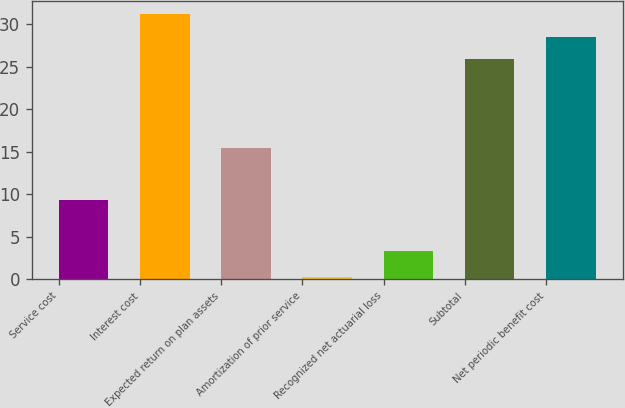Convert chart. <chart><loc_0><loc_0><loc_500><loc_500><bar_chart><fcel>Service cost<fcel>Interest cost<fcel>Expected return on plan assets<fcel>Amortization of prior service<fcel>Recognized net actuarial loss<fcel>Subtotal<fcel>Net periodic benefit cost<nl><fcel>9.3<fcel>31.22<fcel>15.5<fcel>0.3<fcel>3.3<fcel>25.9<fcel>28.56<nl></chart> 